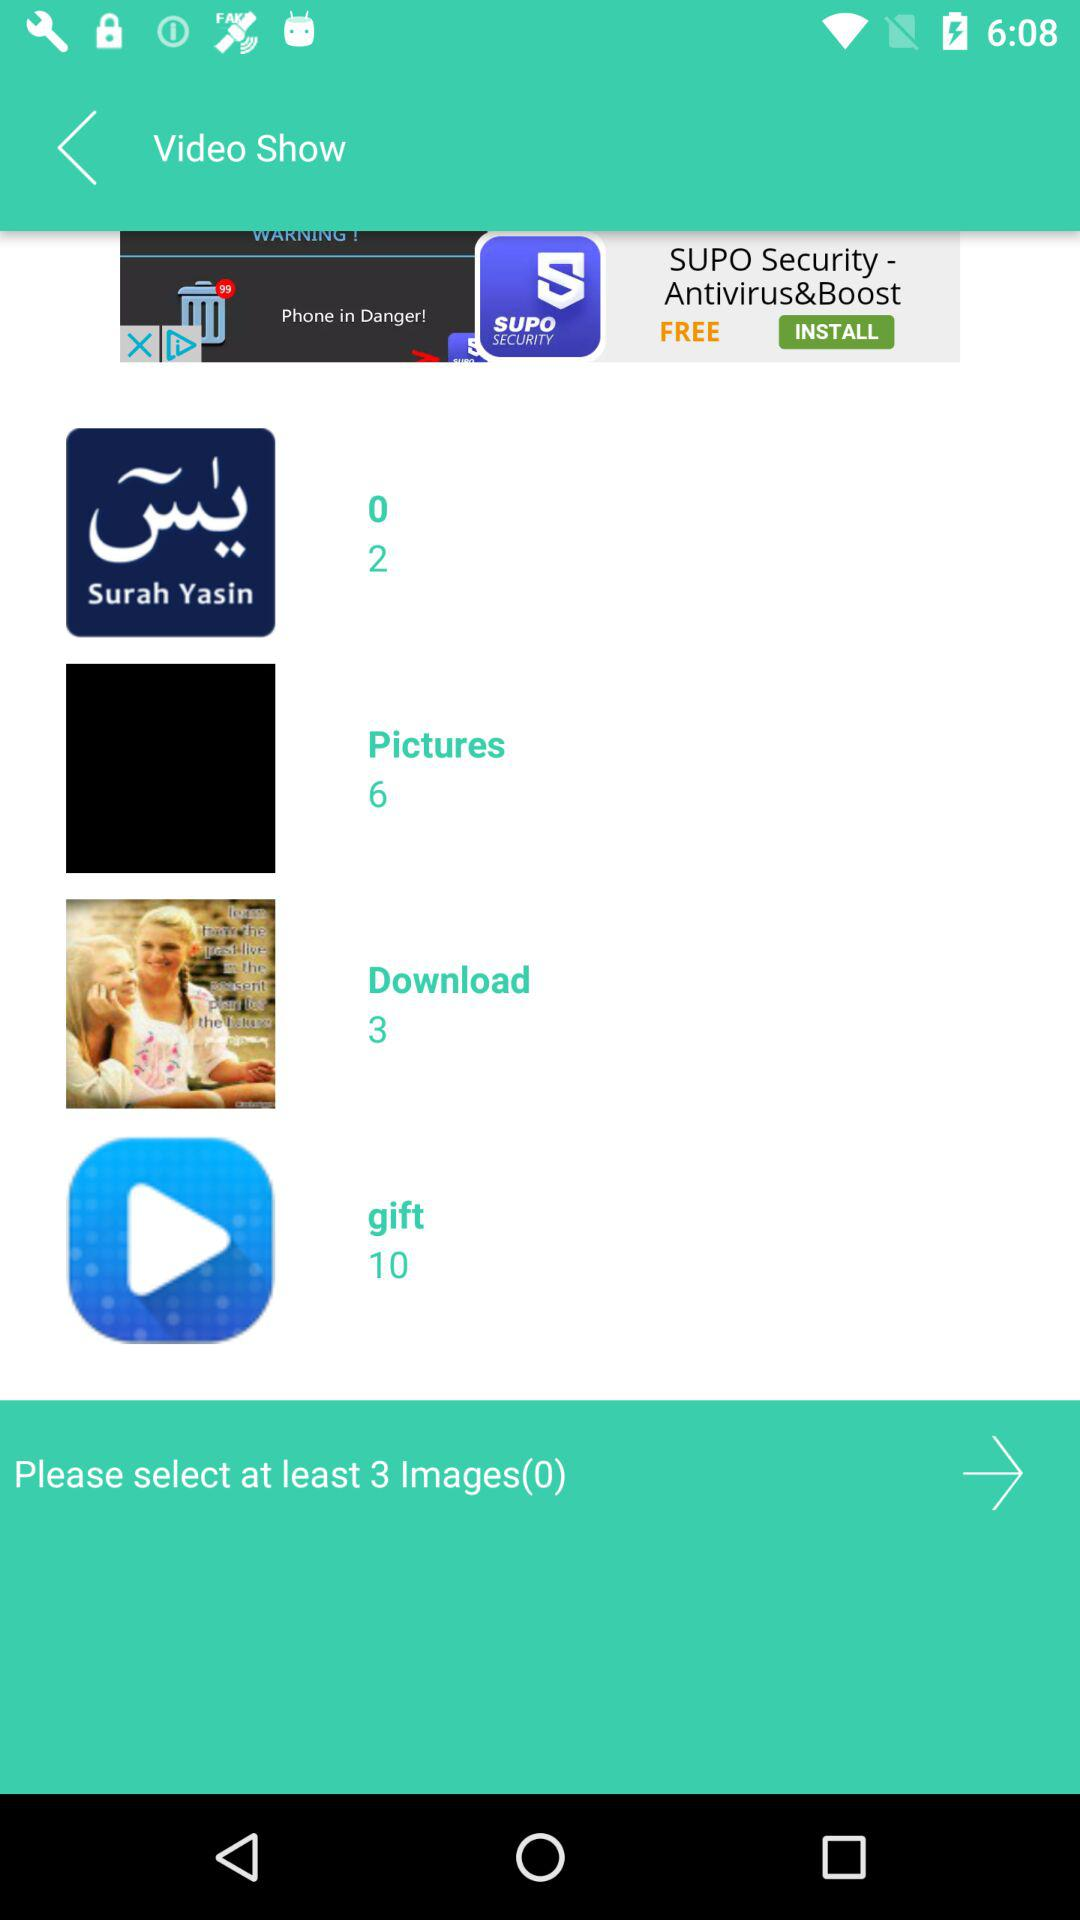How many images need to be selected? There are at least 3 images that need to be selected. 